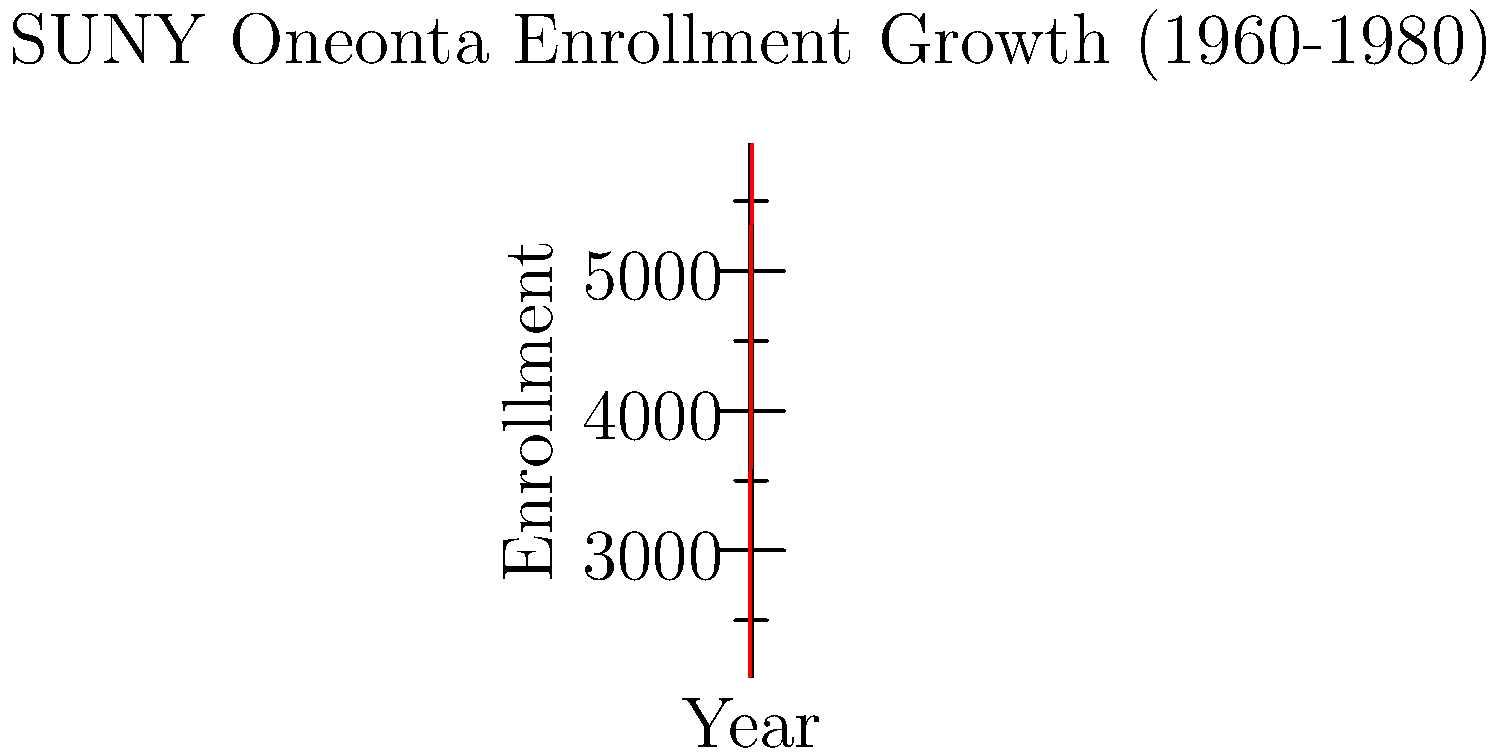During Royal F. Netzer's presidency (1951-1970), SUNY Oneonta experienced significant growth in student enrollment. Based on the line graph, what was the approximate percentage increase in student enrollment from 1960 to 1970? To calculate the percentage increase in student enrollment from 1960 to 1970:

1. Identify the enrollment values:
   1960: 2,100 students
   1970: 4,800 students

2. Calculate the difference:
   4,800 - 2,100 = 2,700 students

3. Divide the increase by the initial value:
   2,700 / 2,100 = 1.2857

4. Convert to percentage:
   1.2857 * 100 = 128.57%

Therefore, the approximate percentage increase in student enrollment from 1960 to 1970 was about 129%.
Answer: 129% 